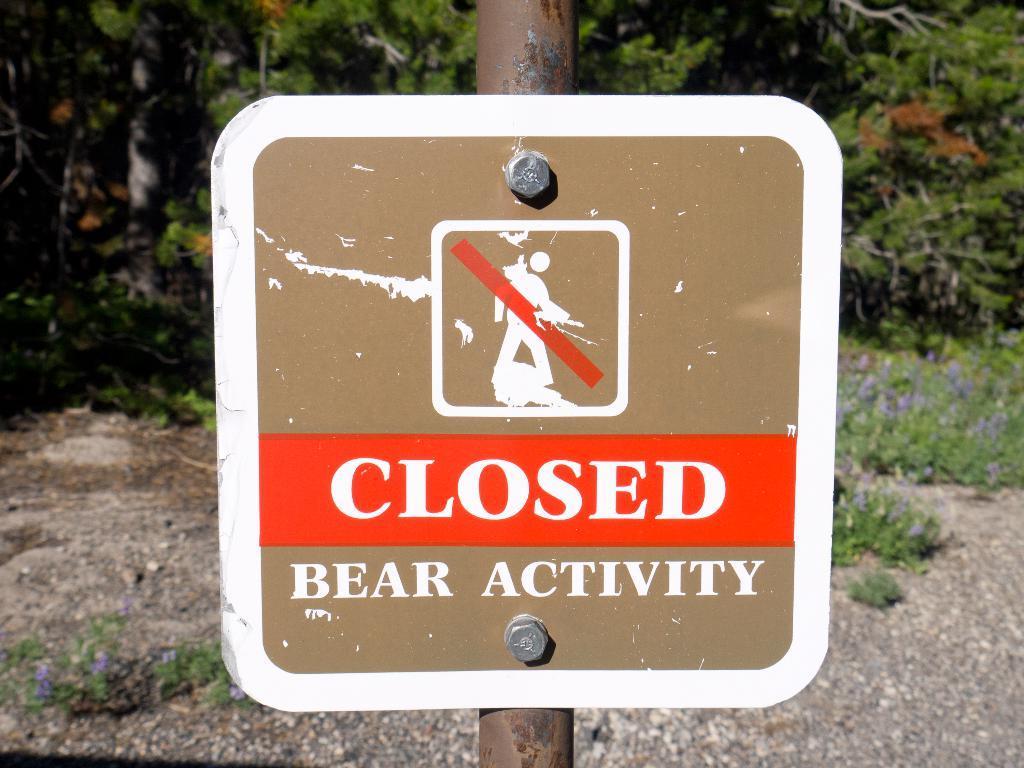Could you give a brief overview of what you see in this image? This image consists of a board fixed to a pole with the help of bolts. At the bottom, there is a ground. In the background, there are trees. 